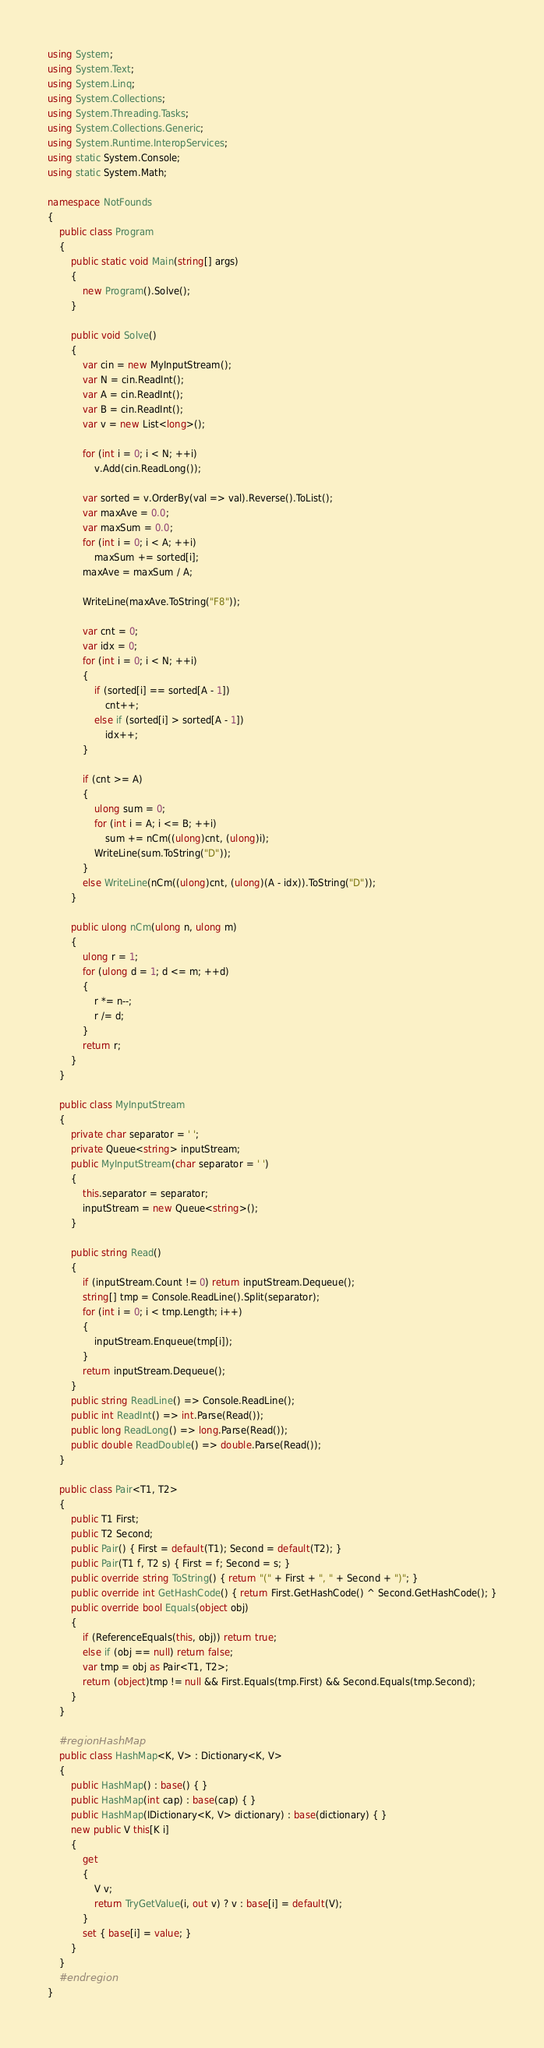<code> <loc_0><loc_0><loc_500><loc_500><_C#_>using System;
using System.Text;
using System.Linq;
using System.Collections;
using System.Threading.Tasks;
using System.Collections.Generic;
using System.Runtime.InteropServices;
using static System.Console;
using static System.Math;

namespace NotFounds
{
    public class Program
    {
        public static void Main(string[] args)
        {
            new Program().Solve();
        }

        public void Solve()
        {
            var cin = new MyInputStream();
            var N = cin.ReadInt();
            var A = cin.ReadInt();
            var B = cin.ReadInt();
            var v = new List<long>();

            for (int i = 0; i < N; ++i)
                v.Add(cin.ReadLong());

            var sorted = v.OrderBy(val => val).Reverse().ToList();
            var maxAve = 0.0;
            var maxSum = 0.0;
            for (int i = 0; i < A; ++i)
                maxSum += sorted[i];
            maxAve = maxSum / A;

            WriteLine(maxAve.ToString("F8"));

            var cnt = 0;
            var idx = 0;
            for (int i = 0; i < N; ++i)
            {
                if (sorted[i] == sorted[A - 1])
                    cnt++;
                else if (sorted[i] > sorted[A - 1])
                    idx++;
            }

            if (cnt >= A)
            {
                ulong sum = 0;
                for (int i = A; i <= B; ++i)
                    sum += nCm((ulong)cnt, (ulong)i);
                WriteLine(sum.ToString("D"));
            }
            else WriteLine(nCm((ulong)cnt, (ulong)(A - idx)).ToString("D"));
        }

        public ulong nCm(ulong n, ulong m)
        {
            ulong r = 1;
            for (ulong d = 1; d <= m; ++d)
            {
                r *= n--;
                r /= d;
            }
            return r;
        }
    }

    public class MyInputStream
    {
        private char separator = ' ';
        private Queue<string> inputStream;
        public MyInputStream(char separator = ' ')
        {
            this.separator = separator;
            inputStream = new Queue<string>();
        }

        public string Read()
        {
            if (inputStream.Count != 0) return inputStream.Dequeue();
            string[] tmp = Console.ReadLine().Split(separator);
            for (int i = 0; i < tmp.Length; i++)
            {
                inputStream.Enqueue(tmp[i]);
            }
            return inputStream.Dequeue();
        }
        public string ReadLine() => Console.ReadLine();
        public int ReadInt() => int.Parse(Read());
        public long ReadLong() => long.Parse(Read());
        public double ReadDouble() => double.Parse(Read());
    }

    public class Pair<T1, T2>
    {
        public T1 First;
        public T2 Second;
        public Pair() { First = default(T1); Second = default(T2); }
        public Pair(T1 f, T2 s) { First = f; Second = s; }
        public override string ToString() { return "(" + First + ", " + Second + ")"; }
        public override int GetHashCode() { return First.GetHashCode() ^ Second.GetHashCode(); }
        public override bool Equals(object obj)
        {
            if (ReferenceEquals(this, obj)) return true;
            else if (obj == null) return false;
            var tmp = obj as Pair<T1, T2>;
            return (object)tmp != null && First.Equals(tmp.First) && Second.Equals(tmp.Second);
        }
    }

    #region HashMap
    public class HashMap<K, V> : Dictionary<K, V>
    {
        public HashMap() : base() { }
        public HashMap(int cap) : base(cap) { }
        public HashMap(IDictionary<K, V> dictionary) : base(dictionary) { }
        new public V this[K i]
        {
            get
            {
                V v;
                return TryGetValue(i, out v) ? v : base[i] = default(V);
            }
            set { base[i] = value; }
        }
    }
    #endregion
}
</code> 